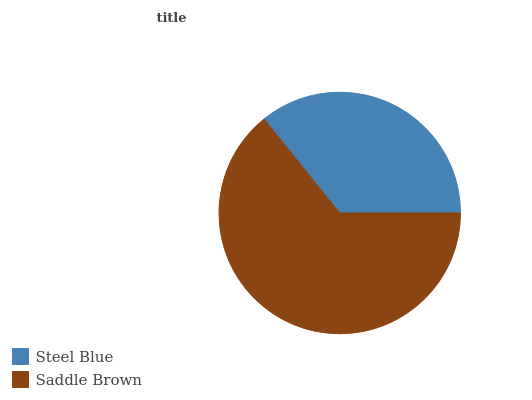Is Steel Blue the minimum?
Answer yes or no. Yes. Is Saddle Brown the maximum?
Answer yes or no. Yes. Is Saddle Brown the minimum?
Answer yes or no. No. Is Saddle Brown greater than Steel Blue?
Answer yes or no. Yes. Is Steel Blue less than Saddle Brown?
Answer yes or no. Yes. Is Steel Blue greater than Saddle Brown?
Answer yes or no. No. Is Saddle Brown less than Steel Blue?
Answer yes or no. No. Is Saddle Brown the high median?
Answer yes or no. Yes. Is Steel Blue the low median?
Answer yes or no. Yes. Is Steel Blue the high median?
Answer yes or no. No. Is Saddle Brown the low median?
Answer yes or no. No. 